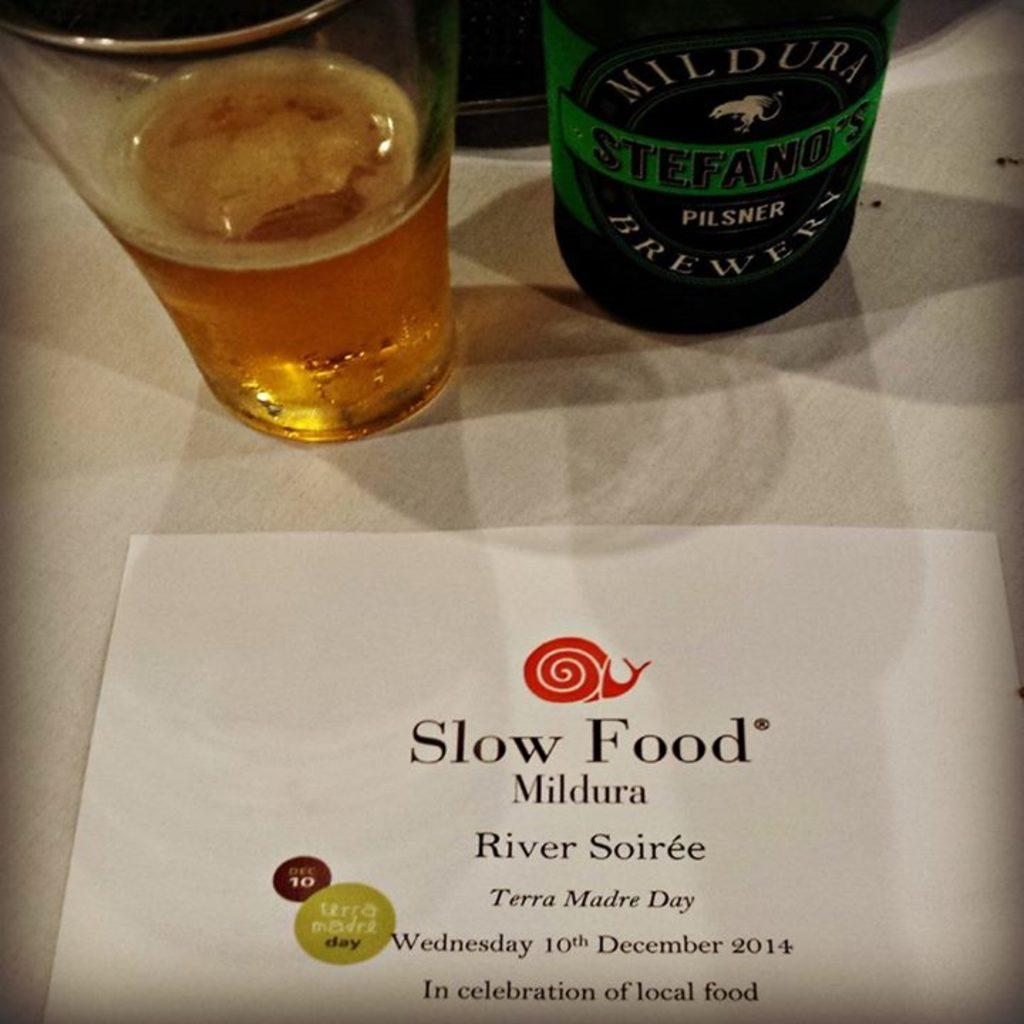Provide a one-sentence caption for the provided image. the words slow food are on the paper. 